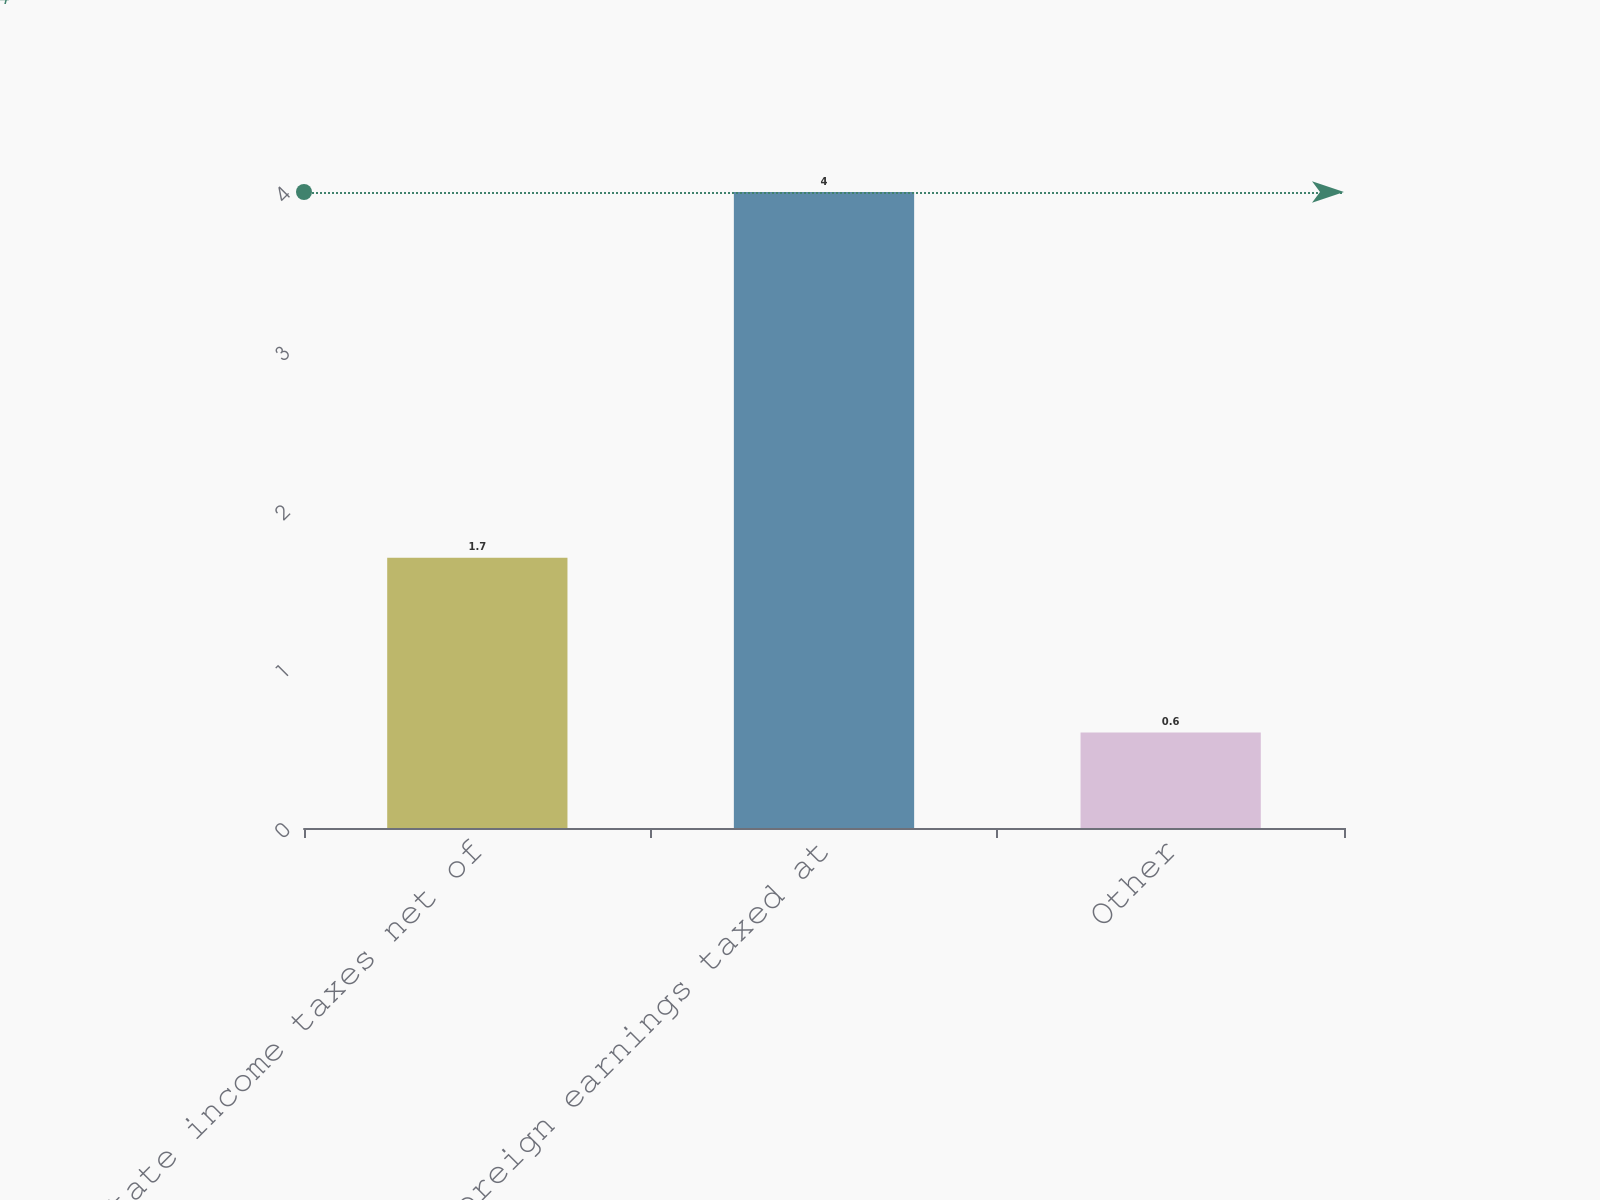Convert chart to OTSL. <chart><loc_0><loc_0><loc_500><loc_500><bar_chart><fcel>State income taxes net of<fcel>Foreign earnings taxed at<fcel>Other<nl><fcel>1.7<fcel>4<fcel>0.6<nl></chart> 